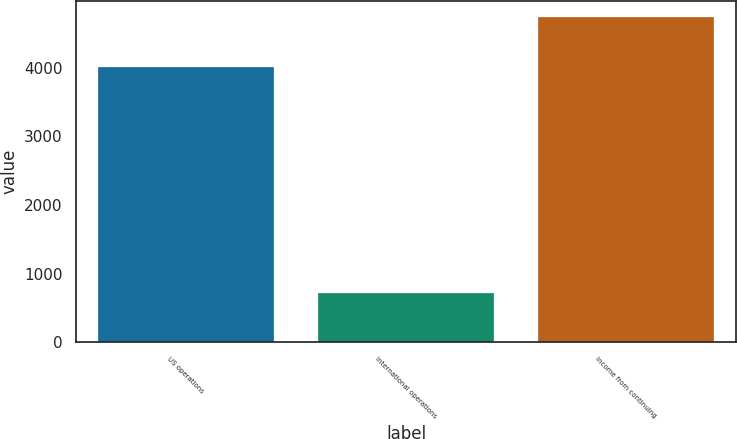Convert chart. <chart><loc_0><loc_0><loc_500><loc_500><bar_chart><fcel>US operations<fcel>International operations<fcel>Income from continuing<nl><fcel>4015<fcel>725<fcel>4740<nl></chart> 